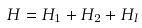Convert formula to latex. <formula><loc_0><loc_0><loc_500><loc_500>H = H _ { 1 } + H _ { 2 } + H _ { I } \,</formula> 